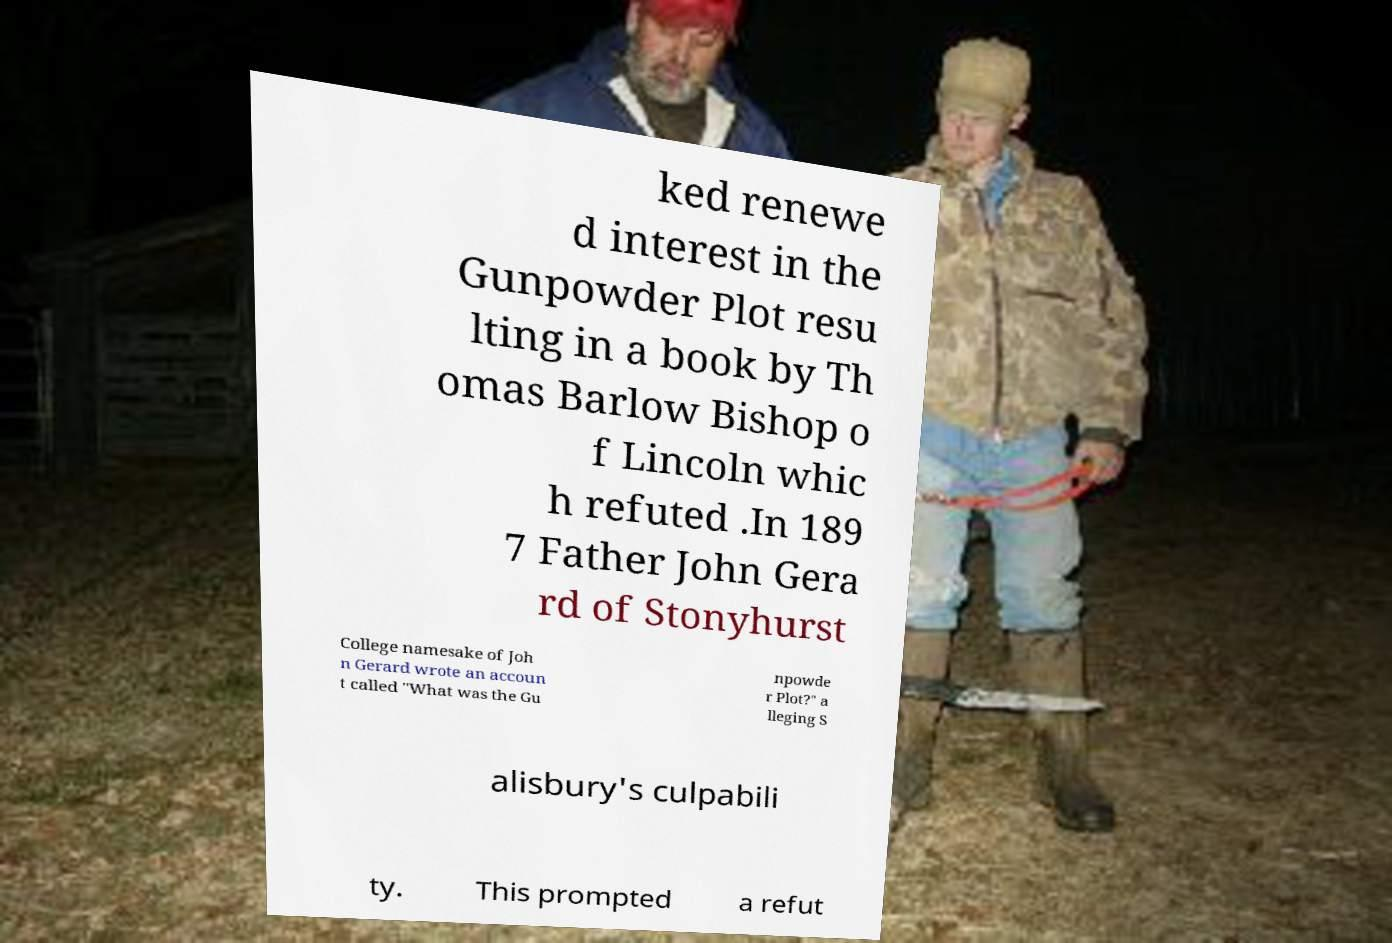I need the written content from this picture converted into text. Can you do that? ked renewe d interest in the Gunpowder Plot resu lting in a book by Th omas Barlow Bishop o f Lincoln whic h refuted .In 189 7 Father John Gera rd of Stonyhurst College namesake of Joh n Gerard wrote an accoun t called "What was the Gu npowde r Plot?" a lleging S alisbury's culpabili ty. This prompted a refut 